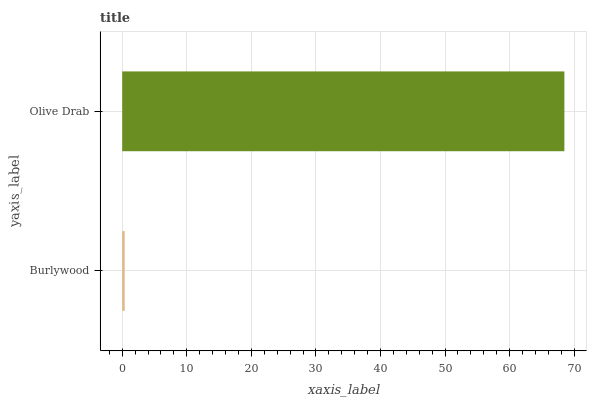Is Burlywood the minimum?
Answer yes or no. Yes. Is Olive Drab the maximum?
Answer yes or no. Yes. Is Olive Drab the minimum?
Answer yes or no. No. Is Olive Drab greater than Burlywood?
Answer yes or no. Yes. Is Burlywood less than Olive Drab?
Answer yes or no. Yes. Is Burlywood greater than Olive Drab?
Answer yes or no. No. Is Olive Drab less than Burlywood?
Answer yes or no. No. Is Olive Drab the high median?
Answer yes or no. Yes. Is Burlywood the low median?
Answer yes or no. Yes. Is Burlywood the high median?
Answer yes or no. No. Is Olive Drab the low median?
Answer yes or no. No. 